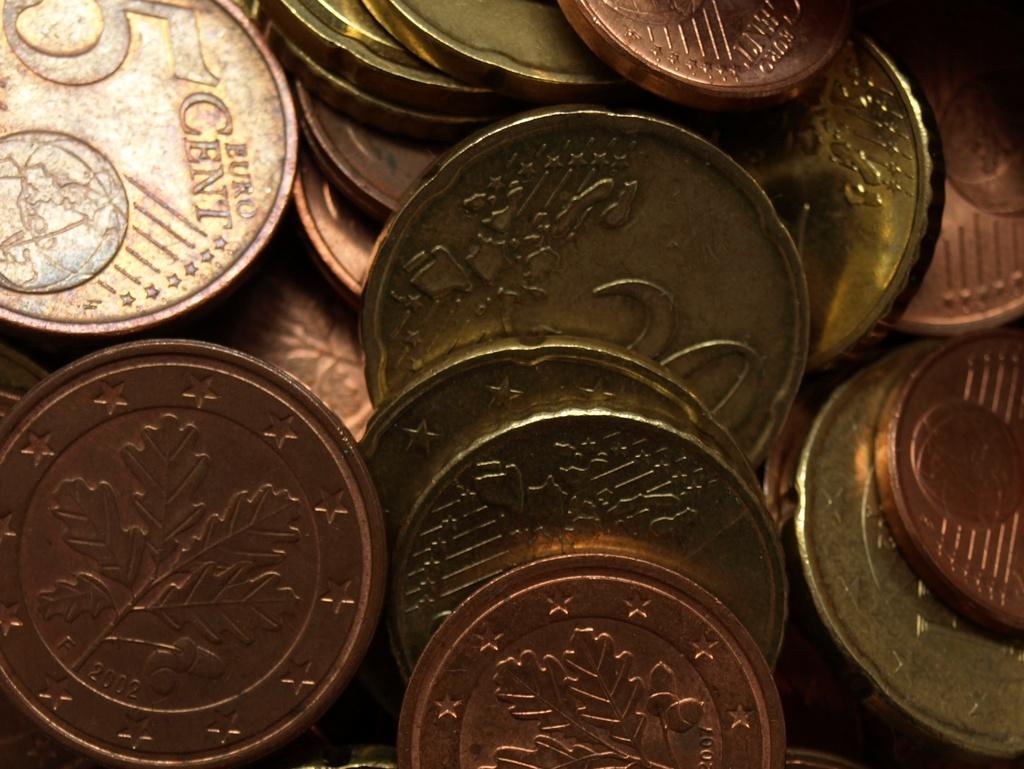What currency is the coin?
Provide a succinct answer. Euro. How much cent is the euro in the top left?
Your answer should be compact. 5. 